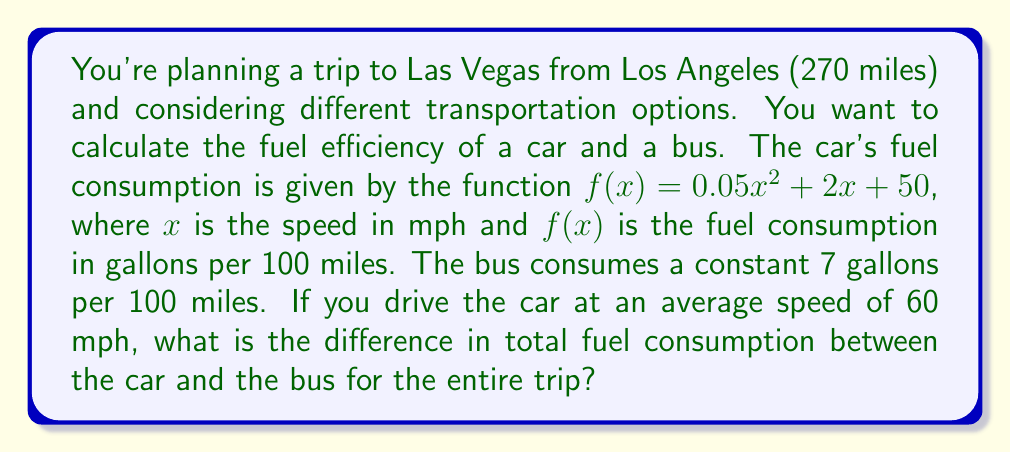Solve this math problem. Let's approach this step-by-step:

1) First, calculate the car's fuel consumption at 60 mph:
   $f(60) = 0.05(60)^2 + 2(60) + 50$
   $= 0.05(3600) + 120 + 50$
   $= 180 + 120 + 50 = 350$ gallons per 100 miles

2) Convert this to gallons per mile:
   $350 / 100 = 3.5$ gallons per mile

3) Calculate total fuel consumption for the car:
   $270 \text{ miles} \times 3.5 \text{ gallons/mile} = 945$ gallons

4) Now for the bus:
   7 gallons per 100 miles = 0.07 gallons per mile

5) Total fuel consumption for the bus:
   $270 \text{ miles} \times 0.07 \text{ gallons/mile} = 18.9$ gallons

6) Calculate the difference:
   $945 - 18.9 = 926.1$ gallons

Therefore, the car consumes 926.1 gallons more than the bus for the entire trip.
Answer: 926.1 gallons 